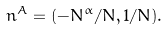Convert formula to latex. <formula><loc_0><loc_0><loc_500><loc_500>n ^ { A } = ( - N ^ { \alpha } / N , 1 / N ) .</formula> 